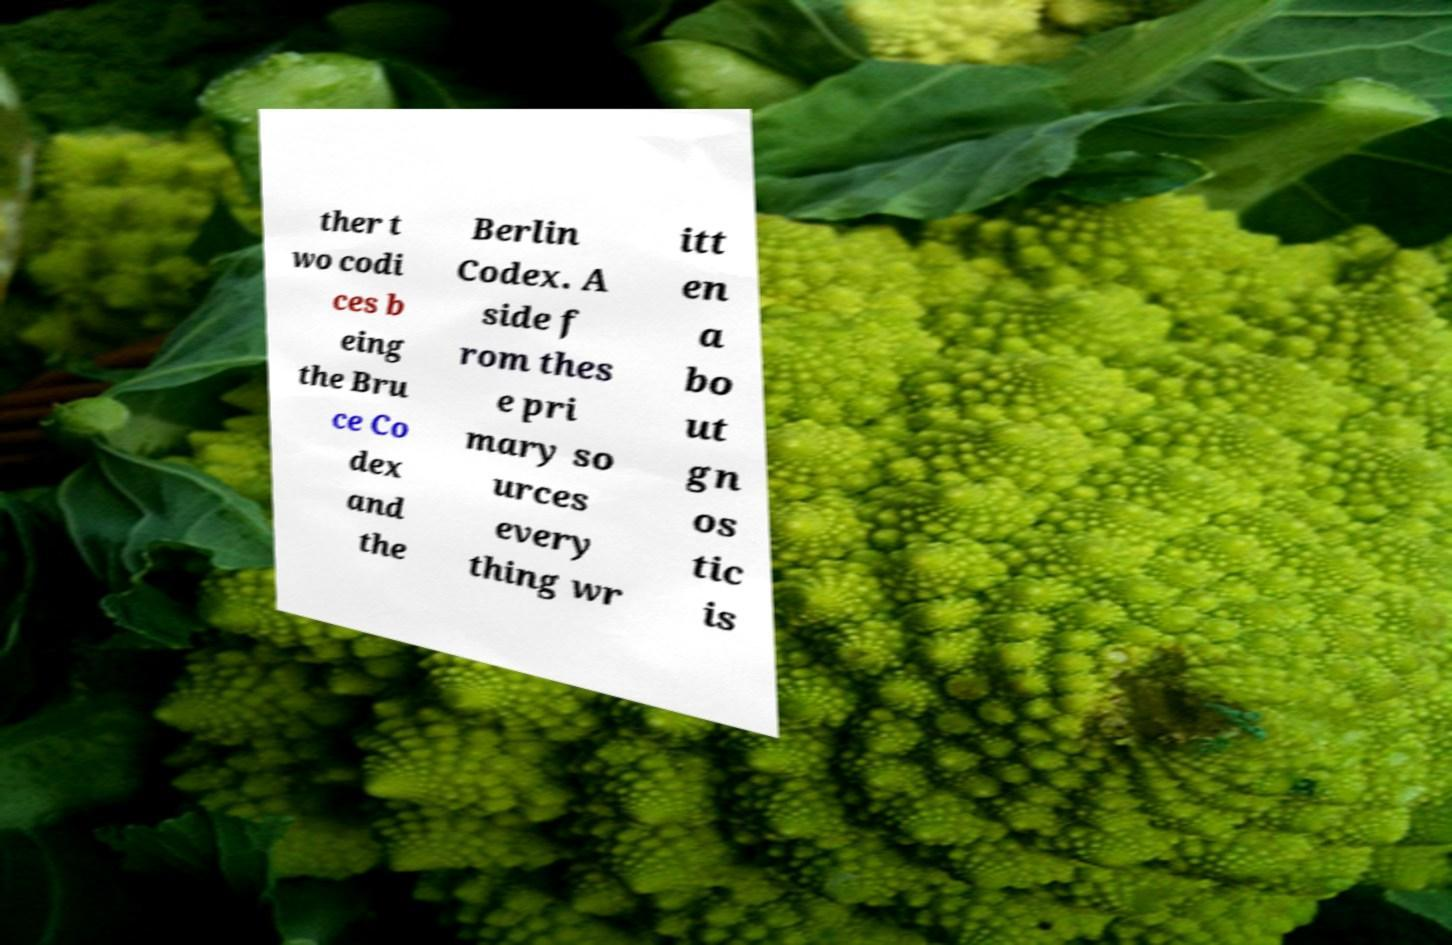For documentation purposes, I need the text within this image transcribed. Could you provide that? ther t wo codi ces b eing the Bru ce Co dex and the Berlin Codex. A side f rom thes e pri mary so urces every thing wr itt en a bo ut gn os tic is 